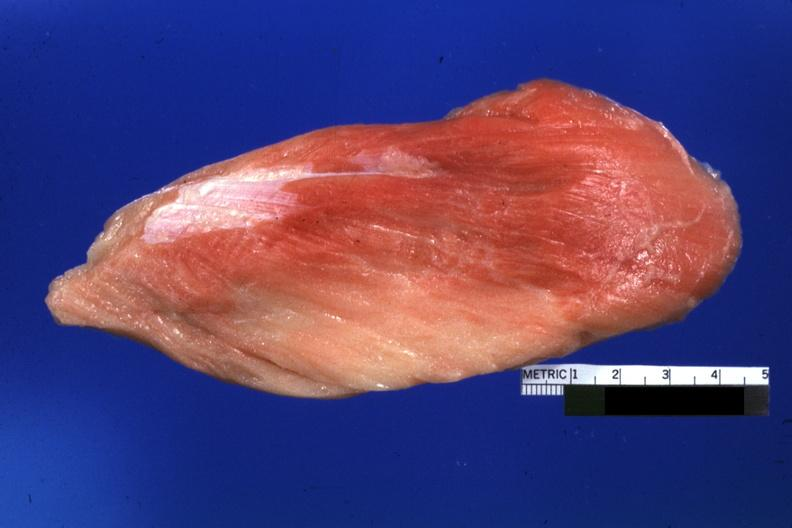does metastatic carcinoid show close-up of muscle with some red persisting?
Answer the question using a single word or phrase. No 